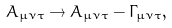Convert formula to latex. <formula><loc_0><loc_0><loc_500><loc_500>A _ { \mu \nu \tau } \rightarrow A _ { \mu \nu \tau } - \Gamma _ { \mu \nu \tau } ,</formula> 